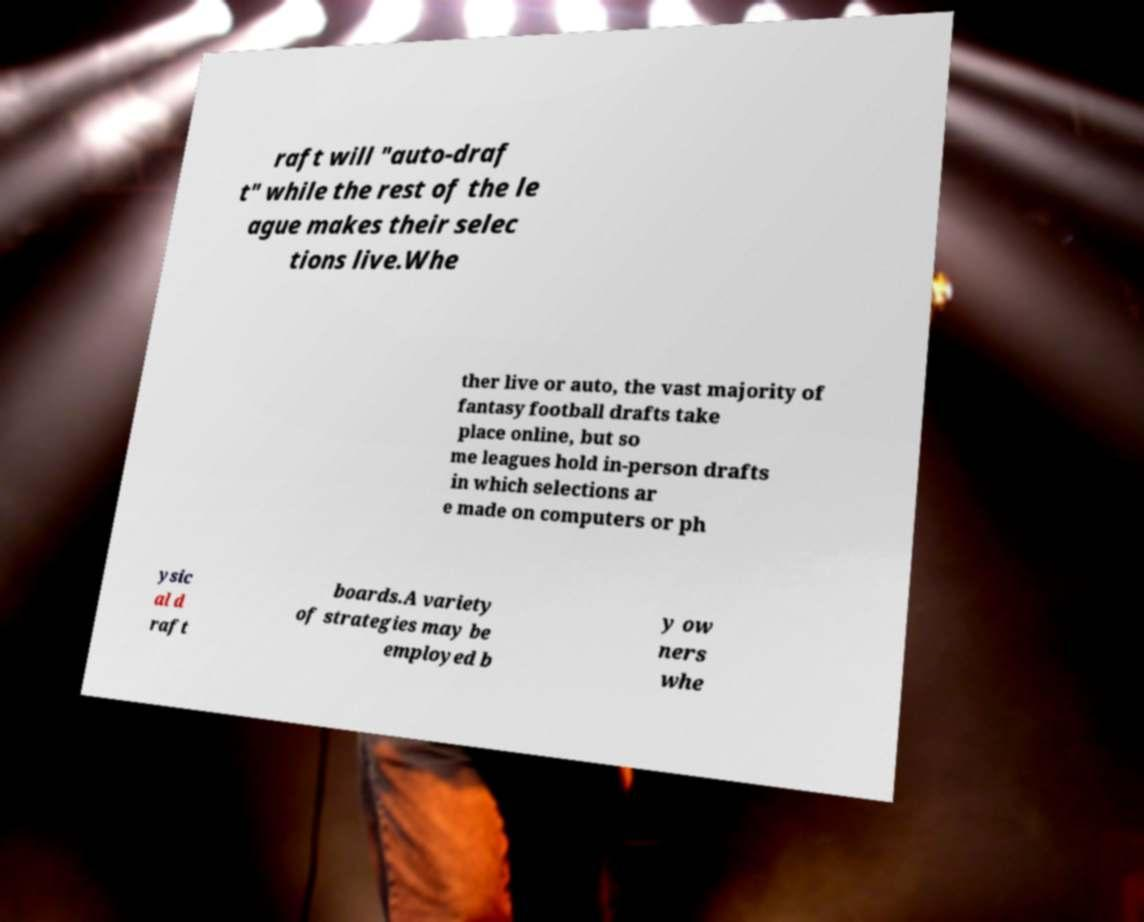Can you accurately transcribe the text from the provided image for me? raft will "auto-draf t" while the rest of the le ague makes their selec tions live.Whe ther live or auto, the vast majority of fantasy football drafts take place online, but so me leagues hold in-person drafts in which selections ar e made on computers or ph ysic al d raft boards.A variety of strategies may be employed b y ow ners whe 